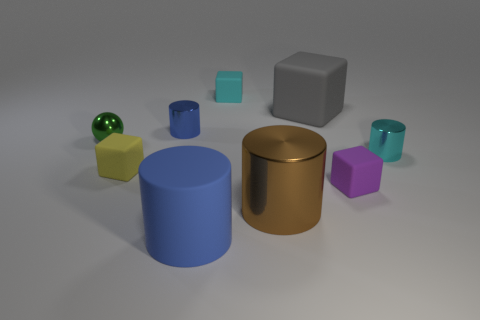Subtract 1 cylinders. How many cylinders are left? 3 Subtract all red blocks. Subtract all cyan cylinders. How many blocks are left? 4 Add 1 green metal objects. How many objects exist? 10 Subtract all cylinders. How many objects are left? 5 Add 5 small metallic things. How many small metallic things exist? 8 Subtract 1 brown cylinders. How many objects are left? 8 Subtract all small yellow matte objects. Subtract all tiny objects. How many objects are left? 2 Add 9 tiny cyan metallic objects. How many tiny cyan metallic objects are left? 10 